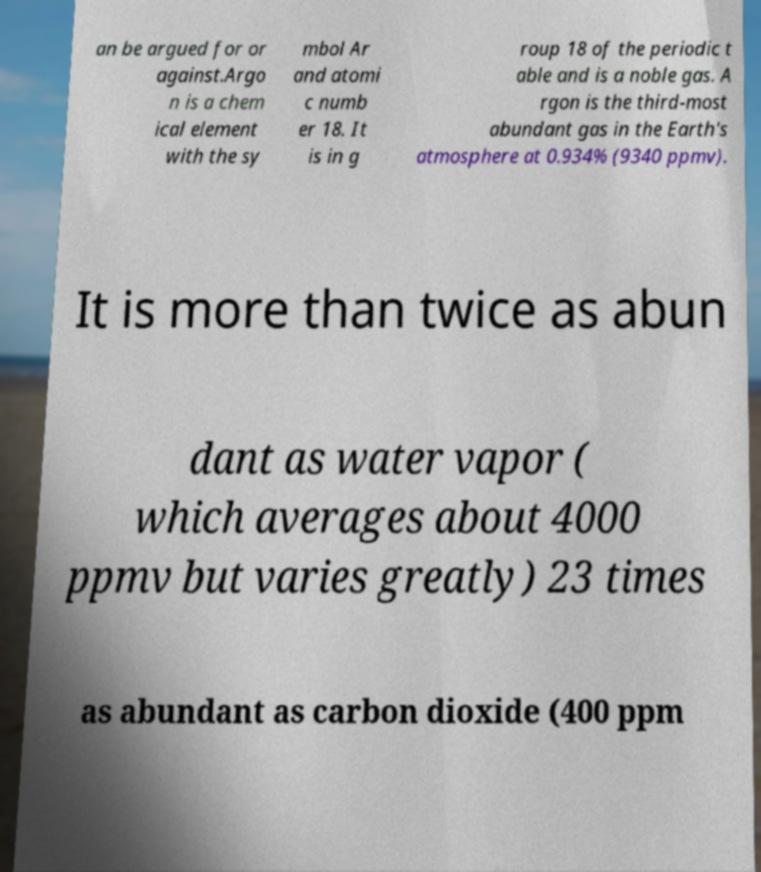Please read and relay the text visible in this image. What does it say? an be argued for or against.Argo n is a chem ical element with the sy mbol Ar and atomi c numb er 18. It is in g roup 18 of the periodic t able and is a noble gas. A rgon is the third-most abundant gas in the Earth's atmosphere at 0.934% (9340 ppmv). It is more than twice as abun dant as water vapor ( which averages about 4000 ppmv but varies greatly) 23 times as abundant as carbon dioxide (400 ppm 